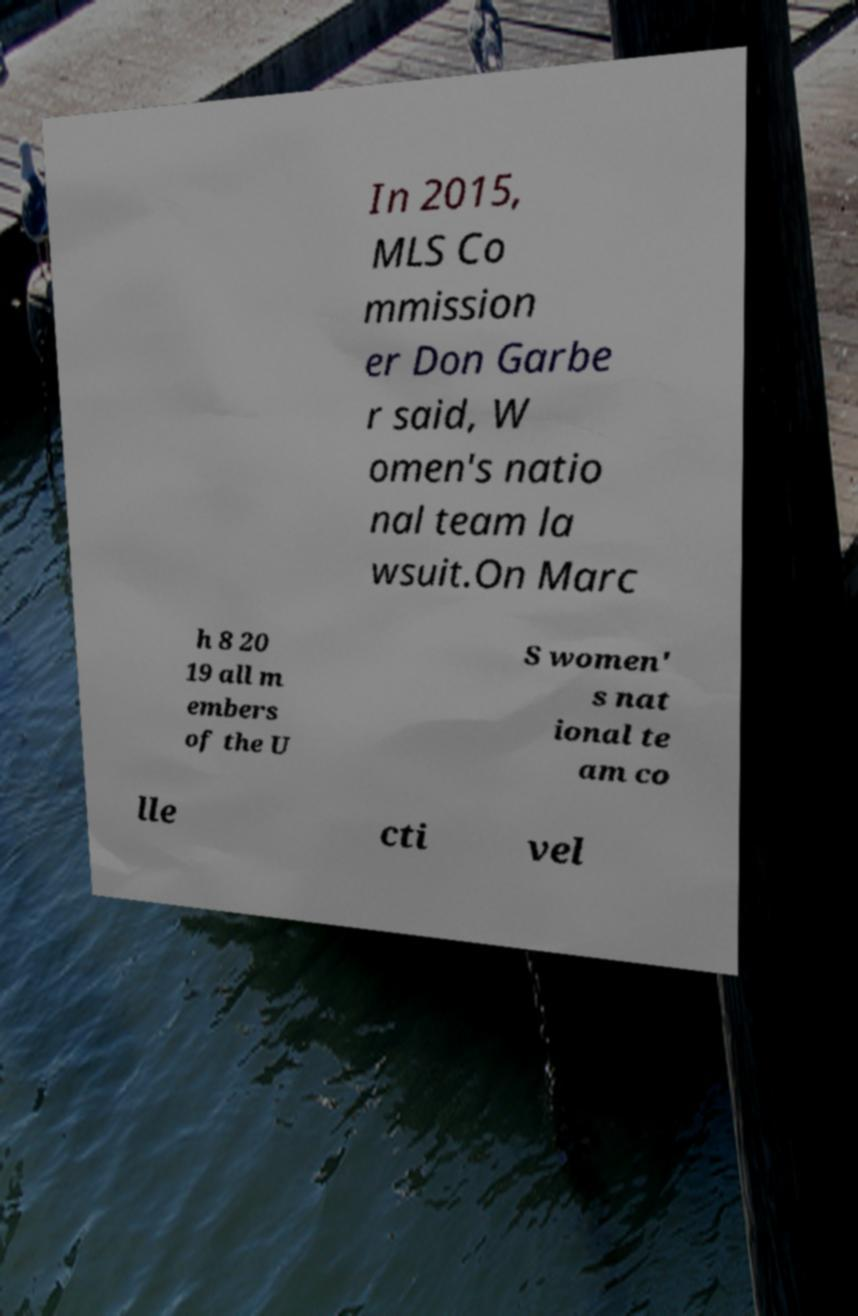I need the written content from this picture converted into text. Can you do that? In 2015, MLS Co mmission er Don Garbe r said, W omen's natio nal team la wsuit.On Marc h 8 20 19 all m embers of the U S women' s nat ional te am co lle cti vel 